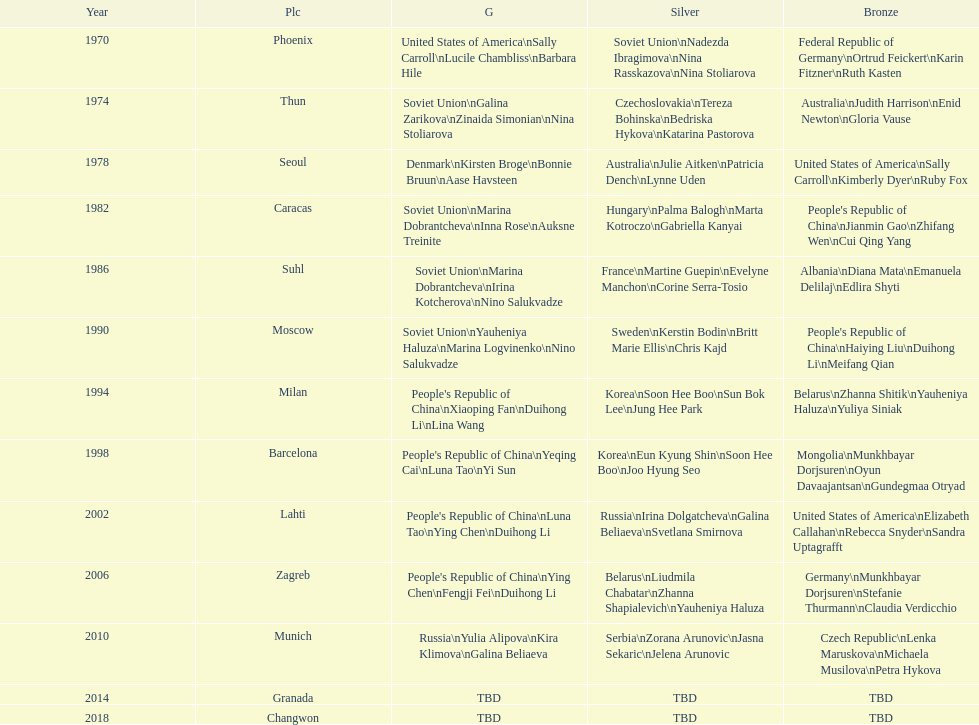What is the first place listed in this chart? Phoenix. 